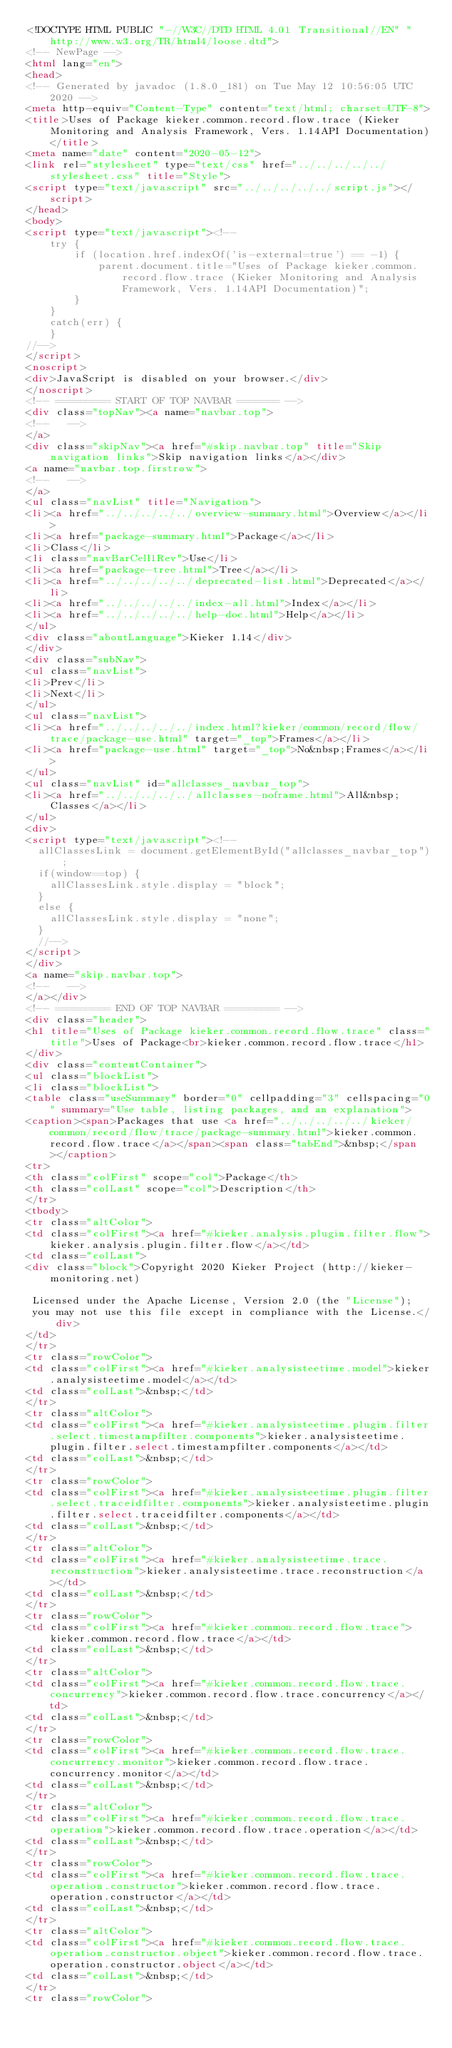<code> <loc_0><loc_0><loc_500><loc_500><_HTML_><!DOCTYPE HTML PUBLIC "-//W3C//DTD HTML 4.01 Transitional//EN" "http://www.w3.org/TR/html4/loose.dtd">
<!-- NewPage -->
<html lang="en">
<head>
<!-- Generated by javadoc (1.8.0_181) on Tue May 12 10:56:05 UTC 2020 -->
<meta http-equiv="Content-Type" content="text/html; charset=UTF-8">
<title>Uses of Package kieker.common.record.flow.trace (Kieker Monitoring and Analysis Framework, Vers. 1.14API Documentation)</title>
<meta name="date" content="2020-05-12">
<link rel="stylesheet" type="text/css" href="../../../../../stylesheet.css" title="Style">
<script type="text/javascript" src="../../../../../script.js"></script>
</head>
<body>
<script type="text/javascript"><!--
    try {
        if (location.href.indexOf('is-external=true') == -1) {
            parent.document.title="Uses of Package kieker.common.record.flow.trace (Kieker Monitoring and Analysis Framework, Vers. 1.14API Documentation)";
        }
    }
    catch(err) {
    }
//-->
</script>
<noscript>
<div>JavaScript is disabled on your browser.</div>
</noscript>
<!-- ========= START OF TOP NAVBAR ======= -->
<div class="topNav"><a name="navbar.top">
<!--   -->
</a>
<div class="skipNav"><a href="#skip.navbar.top" title="Skip navigation links">Skip navigation links</a></div>
<a name="navbar.top.firstrow">
<!--   -->
</a>
<ul class="navList" title="Navigation">
<li><a href="../../../../../overview-summary.html">Overview</a></li>
<li><a href="package-summary.html">Package</a></li>
<li>Class</li>
<li class="navBarCell1Rev">Use</li>
<li><a href="package-tree.html">Tree</a></li>
<li><a href="../../../../../deprecated-list.html">Deprecated</a></li>
<li><a href="../../../../../index-all.html">Index</a></li>
<li><a href="../../../../../help-doc.html">Help</a></li>
</ul>
<div class="aboutLanguage">Kieker 1.14</div>
</div>
<div class="subNav">
<ul class="navList">
<li>Prev</li>
<li>Next</li>
</ul>
<ul class="navList">
<li><a href="../../../../../index.html?kieker/common/record/flow/trace/package-use.html" target="_top">Frames</a></li>
<li><a href="package-use.html" target="_top">No&nbsp;Frames</a></li>
</ul>
<ul class="navList" id="allclasses_navbar_top">
<li><a href="../../../../../allclasses-noframe.html">All&nbsp;Classes</a></li>
</ul>
<div>
<script type="text/javascript"><!--
  allClassesLink = document.getElementById("allclasses_navbar_top");
  if(window==top) {
    allClassesLink.style.display = "block";
  }
  else {
    allClassesLink.style.display = "none";
  }
  //-->
</script>
</div>
<a name="skip.navbar.top">
<!--   -->
</a></div>
<!-- ========= END OF TOP NAVBAR ========= -->
<div class="header">
<h1 title="Uses of Package kieker.common.record.flow.trace" class="title">Uses of Package<br>kieker.common.record.flow.trace</h1>
</div>
<div class="contentContainer">
<ul class="blockList">
<li class="blockList">
<table class="useSummary" border="0" cellpadding="3" cellspacing="0" summary="Use table, listing packages, and an explanation">
<caption><span>Packages that use <a href="../../../../../kieker/common/record/flow/trace/package-summary.html">kieker.common.record.flow.trace</a></span><span class="tabEnd">&nbsp;</span></caption>
<tr>
<th class="colFirst" scope="col">Package</th>
<th class="colLast" scope="col">Description</th>
</tr>
<tbody>
<tr class="altColor">
<td class="colFirst"><a href="#kieker.analysis.plugin.filter.flow">kieker.analysis.plugin.filter.flow</a></td>
<td class="colLast">
<div class="block">Copyright 2020 Kieker Project (http://kieker-monitoring.net)

 Licensed under the Apache License, Version 2.0 (the "License");
 you may not use this file except in compliance with the License.</div>
</td>
</tr>
<tr class="rowColor">
<td class="colFirst"><a href="#kieker.analysisteetime.model">kieker.analysisteetime.model</a></td>
<td class="colLast">&nbsp;</td>
</tr>
<tr class="altColor">
<td class="colFirst"><a href="#kieker.analysisteetime.plugin.filter.select.timestampfilter.components">kieker.analysisteetime.plugin.filter.select.timestampfilter.components</a></td>
<td class="colLast">&nbsp;</td>
</tr>
<tr class="rowColor">
<td class="colFirst"><a href="#kieker.analysisteetime.plugin.filter.select.traceidfilter.components">kieker.analysisteetime.plugin.filter.select.traceidfilter.components</a></td>
<td class="colLast">&nbsp;</td>
</tr>
<tr class="altColor">
<td class="colFirst"><a href="#kieker.analysisteetime.trace.reconstruction">kieker.analysisteetime.trace.reconstruction</a></td>
<td class="colLast">&nbsp;</td>
</tr>
<tr class="rowColor">
<td class="colFirst"><a href="#kieker.common.record.flow.trace">kieker.common.record.flow.trace</a></td>
<td class="colLast">&nbsp;</td>
</tr>
<tr class="altColor">
<td class="colFirst"><a href="#kieker.common.record.flow.trace.concurrency">kieker.common.record.flow.trace.concurrency</a></td>
<td class="colLast">&nbsp;</td>
</tr>
<tr class="rowColor">
<td class="colFirst"><a href="#kieker.common.record.flow.trace.concurrency.monitor">kieker.common.record.flow.trace.concurrency.monitor</a></td>
<td class="colLast">&nbsp;</td>
</tr>
<tr class="altColor">
<td class="colFirst"><a href="#kieker.common.record.flow.trace.operation">kieker.common.record.flow.trace.operation</a></td>
<td class="colLast">&nbsp;</td>
</tr>
<tr class="rowColor">
<td class="colFirst"><a href="#kieker.common.record.flow.trace.operation.constructor">kieker.common.record.flow.trace.operation.constructor</a></td>
<td class="colLast">&nbsp;</td>
</tr>
<tr class="altColor">
<td class="colFirst"><a href="#kieker.common.record.flow.trace.operation.constructor.object">kieker.common.record.flow.trace.operation.constructor.object</a></td>
<td class="colLast">&nbsp;</td>
</tr>
<tr class="rowColor"></code> 